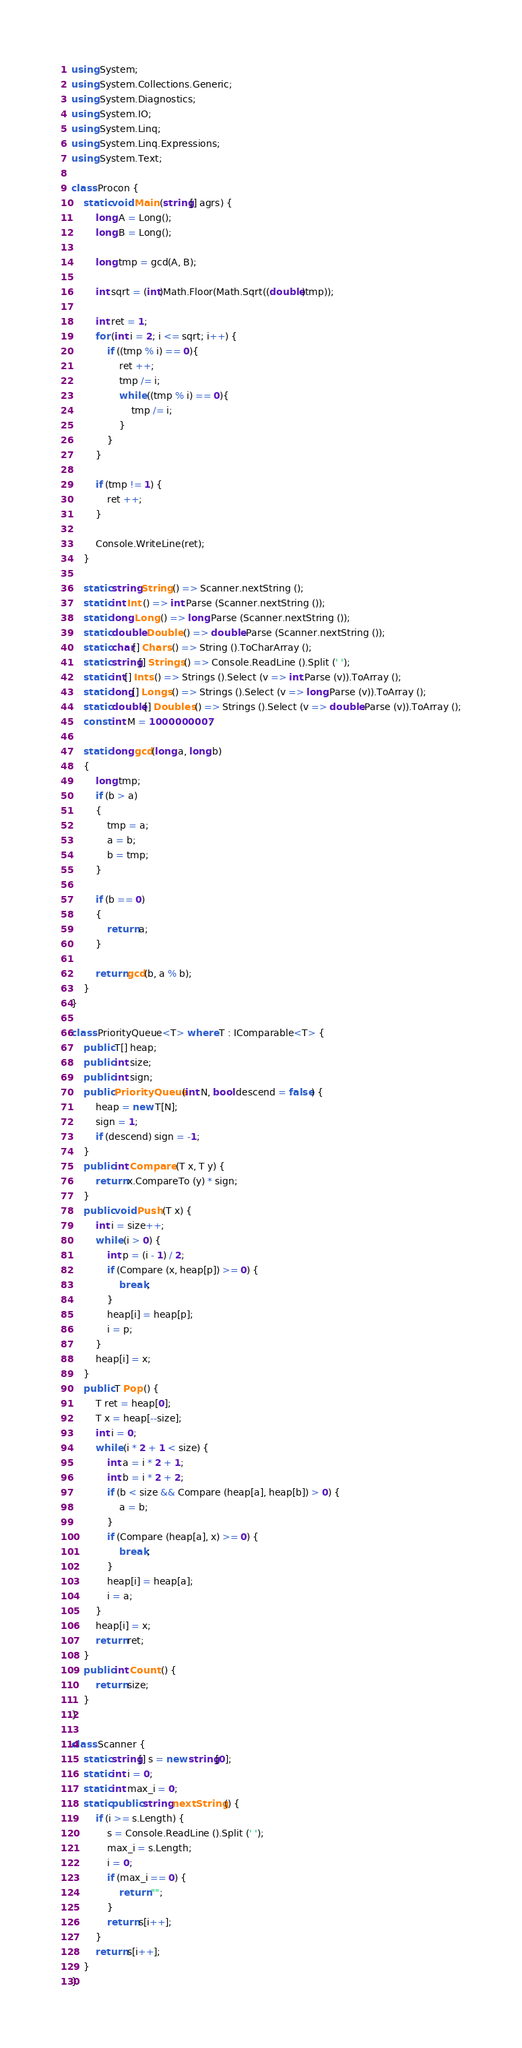<code> <loc_0><loc_0><loc_500><loc_500><_C#_>using System;
using System.Collections.Generic;
using System.Diagnostics;
using System.IO;
using System.Linq;
using System.Linq.Expressions;
using System.Text;

class Procon {
    static void Main (string[] agrs) {
        long A = Long();
        long B = Long();

        long tmp = gcd(A, B);

        int sqrt = (int)Math.Floor(Math.Sqrt((double)tmp));

        int ret = 1;
        for (int i = 2; i <= sqrt; i++) {
            if ((tmp % i) == 0){
                ret ++;
                tmp /= i;
                while ((tmp % i) == 0){
                    tmp /= i;
                }
            }
        }

        if (tmp != 1) {
            ret ++;
        }

        Console.WriteLine(ret);
    }

    static string String () => Scanner.nextString ();
    static int Int () => int.Parse (Scanner.nextString ());
    static long Long () => long.Parse (Scanner.nextString ());
    static double Double () => double.Parse (Scanner.nextString ());
    static char[] Chars () => String ().ToCharArray ();
    static string[] Strings () => Console.ReadLine ().Split (' ');
    static int[] Ints () => Strings ().Select (v => int.Parse (v)).ToArray ();
    static long[] Longs () => Strings ().Select (v => long.Parse (v)).ToArray ();
    static double[] Doubles () => Strings ().Select (v => double.Parse (v)).ToArray ();
    const int M = 1000000007;

    static long gcd(long a, long b)
    {
        long tmp;
        if (b > a)
        {
            tmp = a;
            a = b;
            b = tmp;
        }

        if (b == 0)
        {
            return a;
        }

        return gcd(b, a % b);
    }
}

class PriorityQueue<T> where T : IComparable<T> {
    public T[] heap;
    public int size;
    public int sign;
    public PriorityQueue (int N, bool descend = false) {
        heap = new T[N];
        sign = 1;
        if (descend) sign = -1;
    }
    public int Compare (T x, T y) {
        return x.CompareTo (y) * sign;
    }
    public void Push (T x) {
        int i = size++;
        while (i > 0) {
            int p = (i - 1) / 2;
            if (Compare (x, heap[p]) >= 0) {
                break;
            }
            heap[i] = heap[p];
            i = p;
        }
        heap[i] = x;
    }
    public T Pop () {
        T ret = heap[0];
        T x = heap[--size];
        int i = 0;
        while (i * 2 + 1 < size) {
            int a = i * 2 + 1;
            int b = i * 2 + 2;
            if (b < size && Compare (heap[a], heap[b]) > 0) {
                a = b;
            }
            if (Compare (heap[a], x) >= 0) {
                break;
            }
            heap[i] = heap[a];
            i = a;
        }
        heap[i] = x;
        return ret;
    }
    public int Count () {
        return size;
    }
}

class Scanner {
    static string[] s = new string[0];
    static int i = 0;
    static int max_i = 0;
    static public string nextString () {
        if (i >= s.Length) {
            s = Console.ReadLine ().Split (' ');
            max_i = s.Length;
            i = 0;
            if (max_i == 0) {
                return "";
            }
            return s[i++];
        }
        return s[i++];
    }
}</code> 